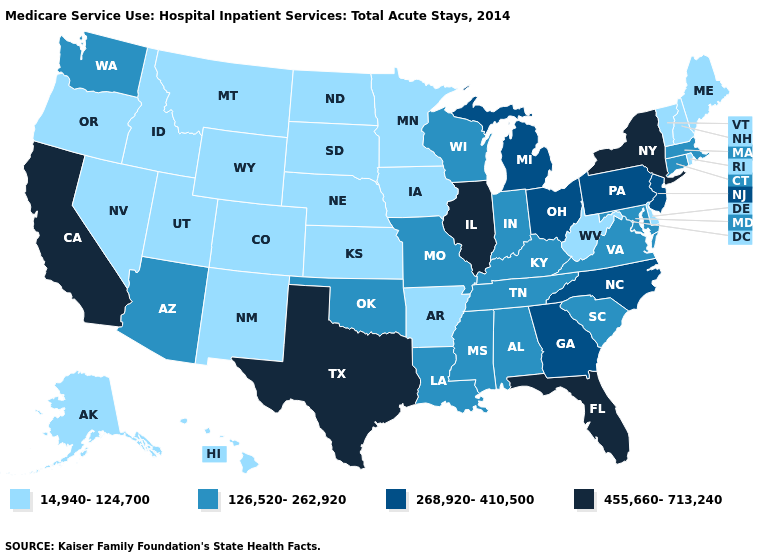Which states hav the highest value in the Northeast?
Write a very short answer. New York. Name the states that have a value in the range 126,520-262,920?
Give a very brief answer. Alabama, Arizona, Connecticut, Indiana, Kentucky, Louisiana, Maryland, Massachusetts, Mississippi, Missouri, Oklahoma, South Carolina, Tennessee, Virginia, Washington, Wisconsin. Which states have the highest value in the USA?
Keep it brief. California, Florida, Illinois, New York, Texas. What is the value of Mississippi?
Short answer required. 126,520-262,920. What is the value of New York?
Give a very brief answer. 455,660-713,240. What is the value of Florida?
Be succinct. 455,660-713,240. Name the states that have a value in the range 126,520-262,920?
Keep it brief. Alabama, Arizona, Connecticut, Indiana, Kentucky, Louisiana, Maryland, Massachusetts, Mississippi, Missouri, Oklahoma, South Carolina, Tennessee, Virginia, Washington, Wisconsin. Name the states that have a value in the range 14,940-124,700?
Keep it brief. Alaska, Arkansas, Colorado, Delaware, Hawaii, Idaho, Iowa, Kansas, Maine, Minnesota, Montana, Nebraska, Nevada, New Hampshire, New Mexico, North Dakota, Oregon, Rhode Island, South Dakota, Utah, Vermont, West Virginia, Wyoming. Name the states that have a value in the range 126,520-262,920?
Give a very brief answer. Alabama, Arizona, Connecticut, Indiana, Kentucky, Louisiana, Maryland, Massachusetts, Mississippi, Missouri, Oklahoma, South Carolina, Tennessee, Virginia, Washington, Wisconsin. Name the states that have a value in the range 126,520-262,920?
Short answer required. Alabama, Arizona, Connecticut, Indiana, Kentucky, Louisiana, Maryland, Massachusetts, Mississippi, Missouri, Oklahoma, South Carolina, Tennessee, Virginia, Washington, Wisconsin. What is the lowest value in the USA?
Keep it brief. 14,940-124,700. Does Georgia have a lower value than Connecticut?
Answer briefly. No. What is the value of Washington?
Write a very short answer. 126,520-262,920. Which states have the lowest value in the USA?
Answer briefly. Alaska, Arkansas, Colorado, Delaware, Hawaii, Idaho, Iowa, Kansas, Maine, Minnesota, Montana, Nebraska, Nevada, New Hampshire, New Mexico, North Dakota, Oregon, Rhode Island, South Dakota, Utah, Vermont, West Virginia, Wyoming. 